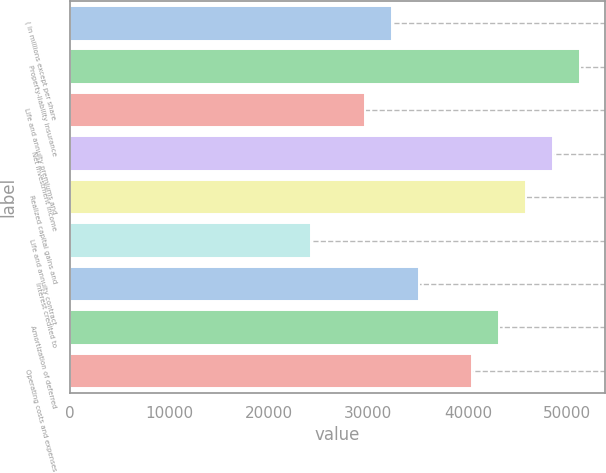<chart> <loc_0><loc_0><loc_500><loc_500><bar_chart><fcel>( in millions except per share<fcel>Property-liability insurance<fcel>Life and annuity premiums and<fcel>Net investment income<fcel>Realized capital gains and<fcel>Life and annuity contract<fcel>Interest credited to<fcel>Amortization of deferred<fcel>Operating costs and expenses<nl><fcel>32360.1<fcel>51235.9<fcel>29663.6<fcel>48539.4<fcel>45842.8<fcel>24270.5<fcel>35056.7<fcel>43146.3<fcel>40449.7<nl></chart> 